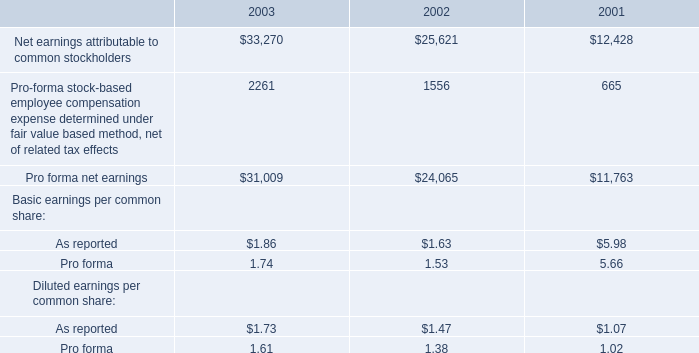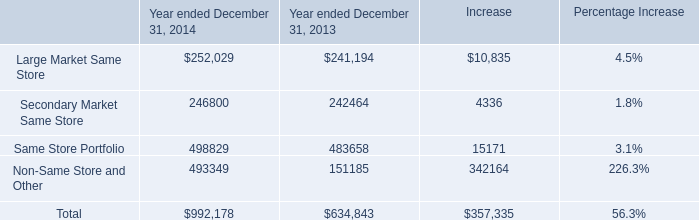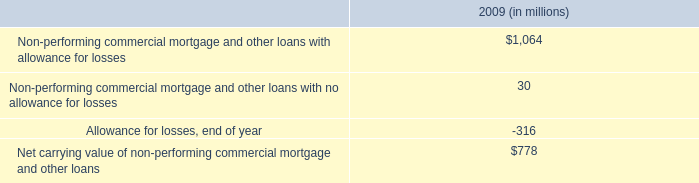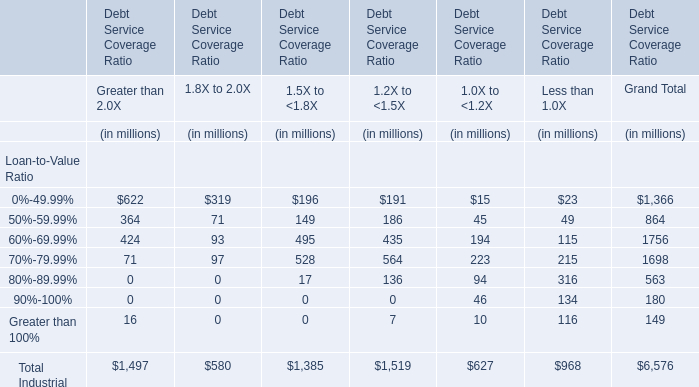What's the sum of all 1.5X to <1.8X that are positive in Debt Service Coverage Ratio? (in million) 
Computations: ((((((196 + 149) + 495) + 528) + 17) + 0) + 0)
Answer: 1385.0. 